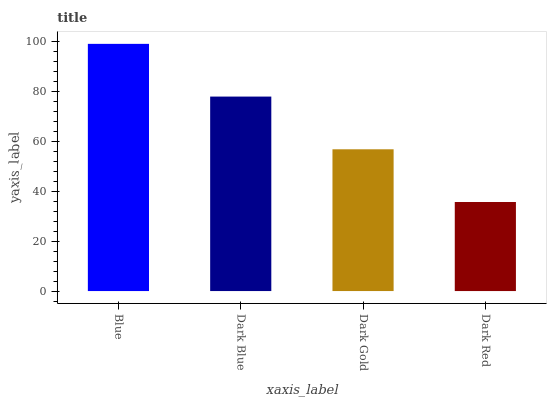Is Dark Blue the minimum?
Answer yes or no. No. Is Dark Blue the maximum?
Answer yes or no. No. Is Blue greater than Dark Blue?
Answer yes or no. Yes. Is Dark Blue less than Blue?
Answer yes or no. Yes. Is Dark Blue greater than Blue?
Answer yes or no. No. Is Blue less than Dark Blue?
Answer yes or no. No. Is Dark Blue the high median?
Answer yes or no. Yes. Is Dark Gold the low median?
Answer yes or no. Yes. Is Dark Gold the high median?
Answer yes or no. No. Is Dark Blue the low median?
Answer yes or no. No. 